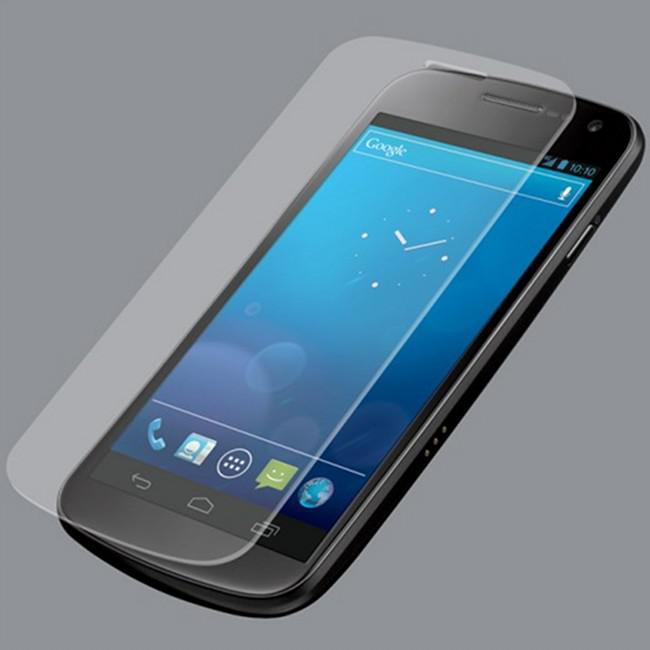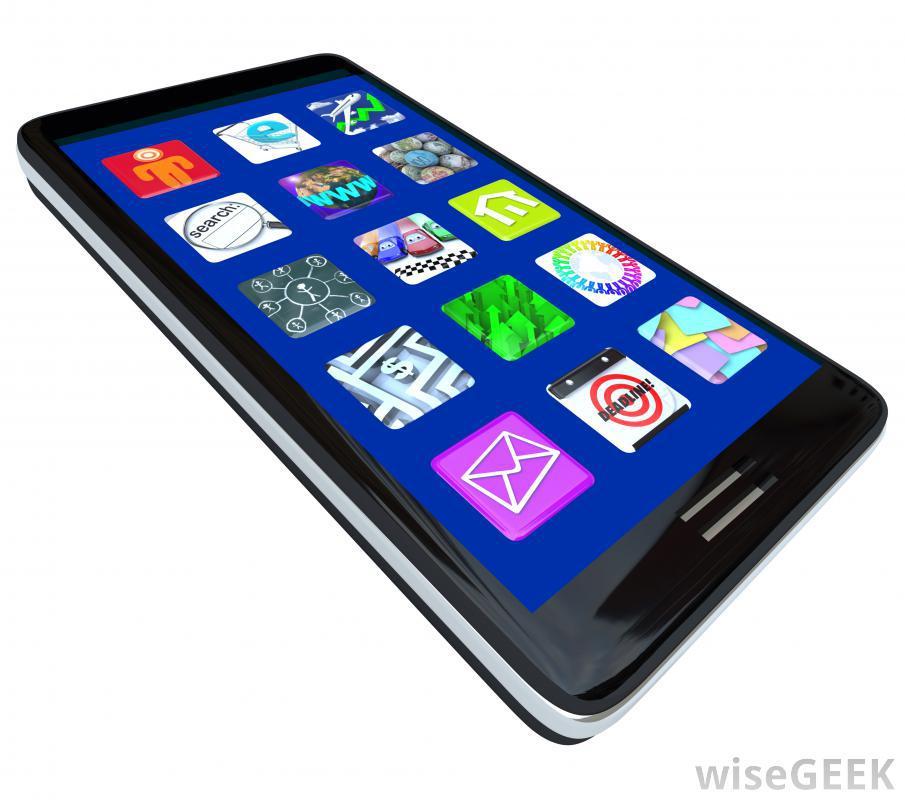The first image is the image on the left, the second image is the image on the right. Analyze the images presented: Is the assertion "In at least one image a there is a single phone with physical buttons on the bottom half of the phone that is attached to a phone screen that is long left to right than up and down." valid? Answer yes or no. No. The first image is the image on the left, the second image is the image on the right. Analyze the images presented: Is the assertion "One image shows a device with a flipped up horizontal, wide screen with something displaying on the screen." valid? Answer yes or no. No. 